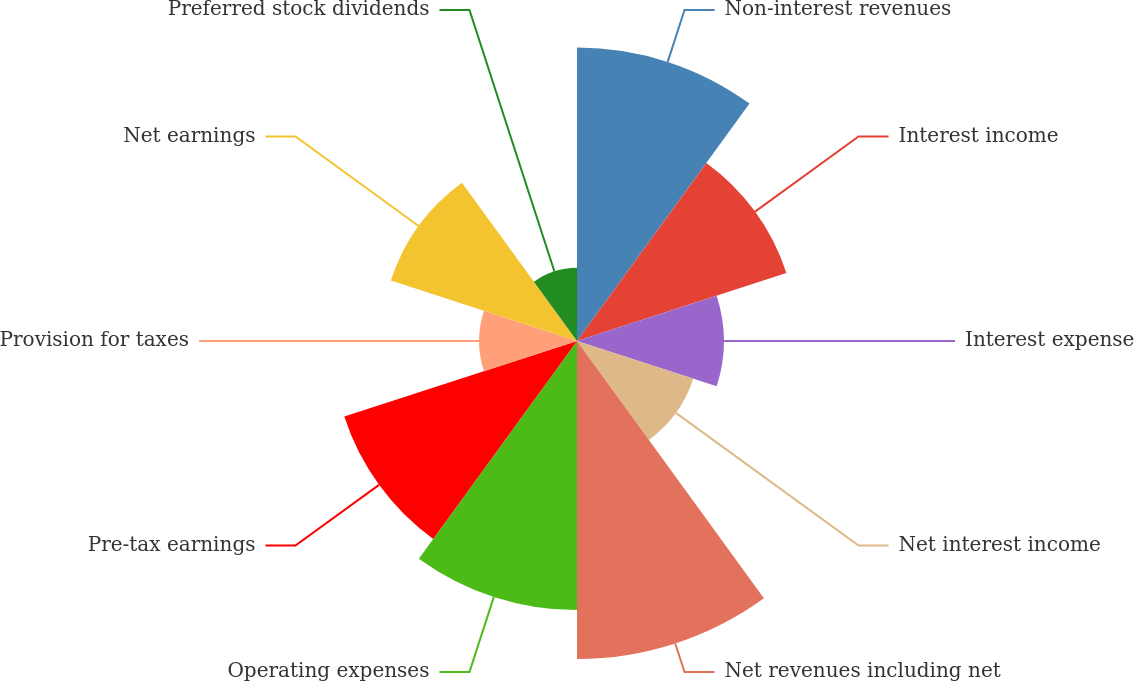Convert chart to OTSL. <chart><loc_0><loc_0><loc_500><loc_500><pie_chart><fcel>Non-interest revenues<fcel>Interest income<fcel>Interest expense<fcel>Net interest income<fcel>Net revenues including net<fcel>Operating expenses<fcel>Pre-tax earnings<fcel>Provision for taxes<fcel>Net earnings<fcel>Preferred stock dividends<nl><fcel>14.81%<fcel>11.11%<fcel>7.41%<fcel>6.17%<fcel>16.05%<fcel>13.58%<fcel>12.35%<fcel>4.94%<fcel>9.88%<fcel>3.7%<nl></chart> 